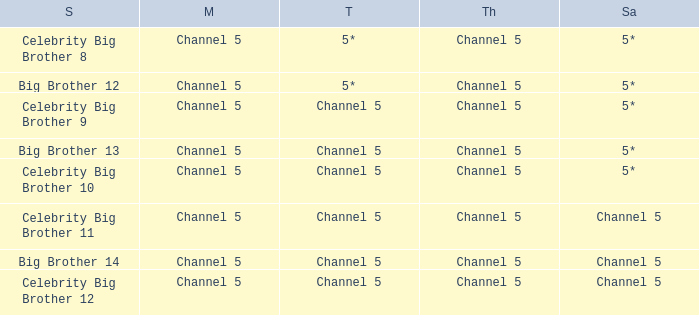Which Tuesday does big brother 12 air? 5*. Can you give me this table as a dict? {'header': ['S', 'M', 'T', 'Th', 'Sa'], 'rows': [['Celebrity Big Brother 8', 'Channel 5', '5*', 'Channel 5', '5*'], ['Big Brother 12', 'Channel 5', '5*', 'Channel 5', '5*'], ['Celebrity Big Brother 9', 'Channel 5', 'Channel 5', 'Channel 5', '5*'], ['Big Brother 13', 'Channel 5', 'Channel 5', 'Channel 5', '5*'], ['Celebrity Big Brother 10', 'Channel 5', 'Channel 5', 'Channel 5', '5*'], ['Celebrity Big Brother 11', 'Channel 5', 'Channel 5', 'Channel 5', 'Channel 5'], ['Big Brother 14', 'Channel 5', 'Channel 5', 'Channel 5', 'Channel 5'], ['Celebrity Big Brother 12', 'Channel 5', 'Channel 5', 'Channel 5', 'Channel 5']]} 